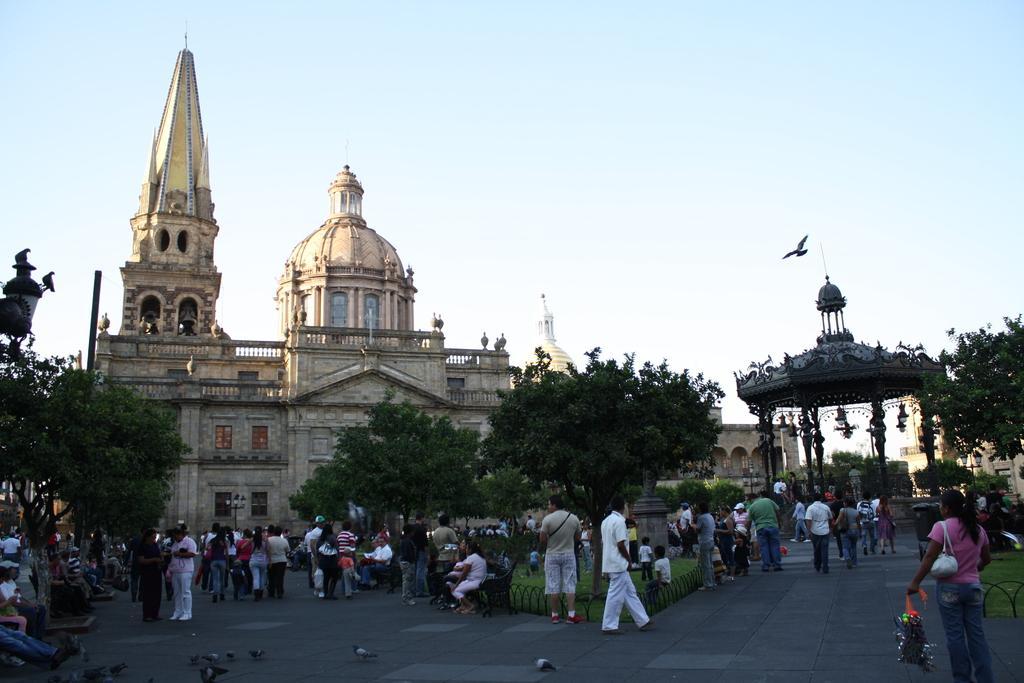Can you describe this image briefly? In this image there are group of people walking, and some of them are sitting on benches and some of them are wearing handbags. In the background there is a palace, trees, plants, and grass. At the bottom there is walkway, on the walkway there are some birds. And on the right side of the image there might be a tower and on the left side there is some object, at the top there is sky. 